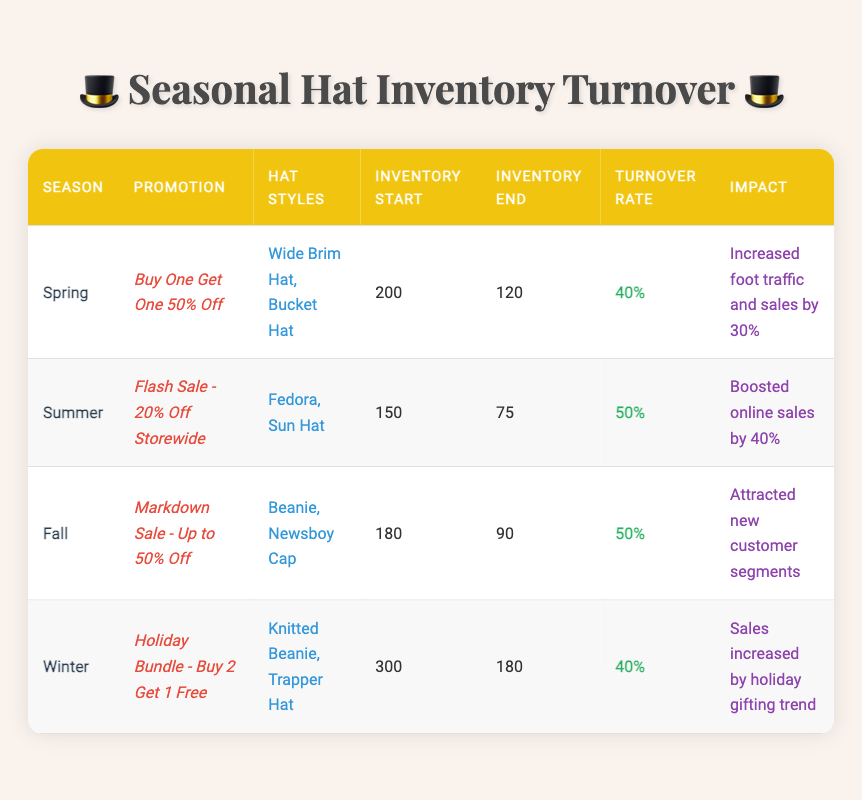What is the turnover rate for the Summer promotion? The turnover rate for Summer, as stated in the table, is directly listed under the "Turnover Rate" column corresponding to the Summer row.
Answer: 50% Which season had the highest inventory at the start? By looking at the "Inventory Start" column, Winter has the highest starting inventory of 300, compared to the other seasons.
Answer: Winter Did the Fall promotion attract new customer segments? Yes, the table indicates that the impact of the Fall promotion specifically states it "Attracted new customer segments."
Answer: Yes What is the total inventory reduction from Spring to Winter? To find this, subtract the inventory at the end of Winter from the inventory at the start of Spring: (200 - 120) + (300 - 180) = 80 + 120 = 200. Therefore, the total inventory reduction is 200.
Answer: 200 Is the impact of the Spring promotion linked to increased foot traffic? Yes, the impact description for Spring mentions "Increased foot traffic and sales by 30%," confirming the relationship.
Answer: Yes Which season had a promotion involving a "Buy 2 Get 1 Free" offer? The Winter season had the "Holiday Bundle - Buy 2 Get 1 Free" promotion as detailed in the table.
Answer: Winter How many hat styles were promoted in the summer season? The table lists two hat styles for Summer: Fedora and Sun Hat, as specified in the "Hat Styles" column.
Answer: 2 Compare the turnover rates of Spring and Fall. Which is higher? The turnover rate for Spring is 40%, while for Fall it is 50%. Since 50% is higher than 40%, Fall has the higher turnover rate.
Answer: Fall What was the impact of the Summer promotion on sales? According to the table, the Summer promotion resulted in a "Boosted online sales by 40%."
Answer: Boosted online sales by 40% 